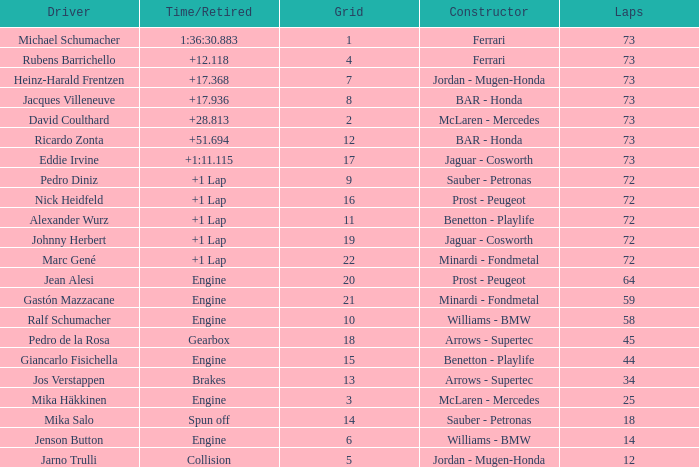How many laps did Jos Verstappen do on Grid 2? 34.0. 